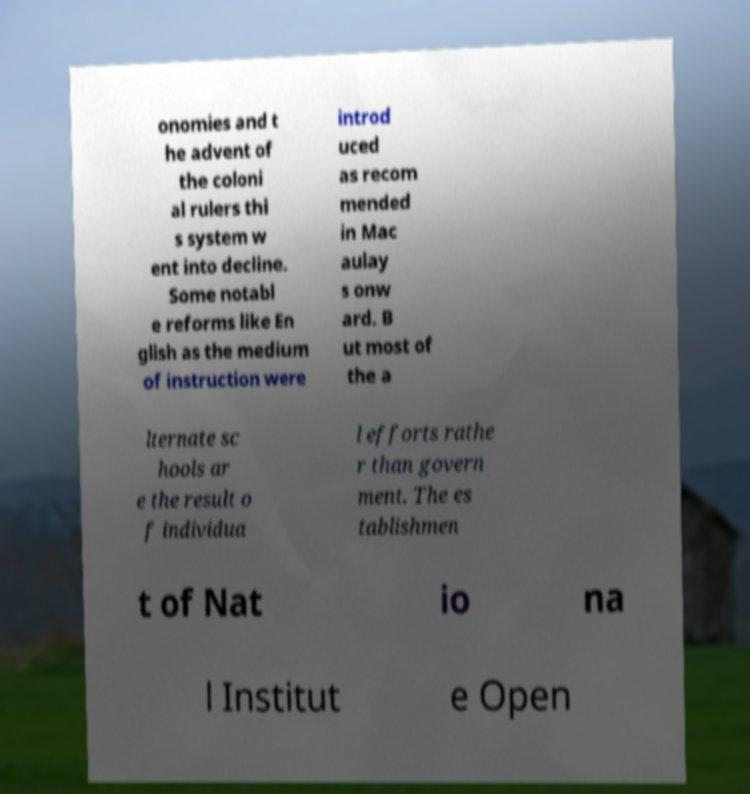Can you read and provide the text displayed in the image?This photo seems to have some interesting text. Can you extract and type it out for me? onomies and t he advent of the coloni al rulers thi s system w ent into decline. Some notabl e reforms like En glish as the medium of instruction were introd uced as recom mended in Mac aulay s onw ard. B ut most of the a lternate sc hools ar e the result o f individua l efforts rathe r than govern ment. The es tablishmen t of Nat io na l Institut e Open 